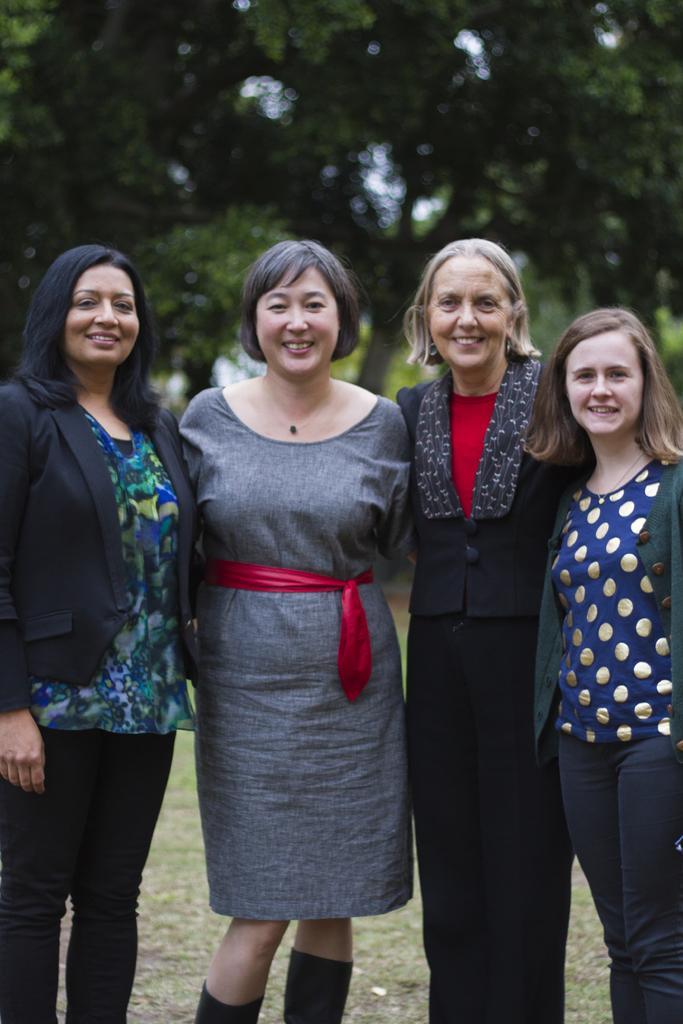Could you give a brief overview of what you see in this image? In this picture we can see four women standing and smiling. There are a few trees in the background. 